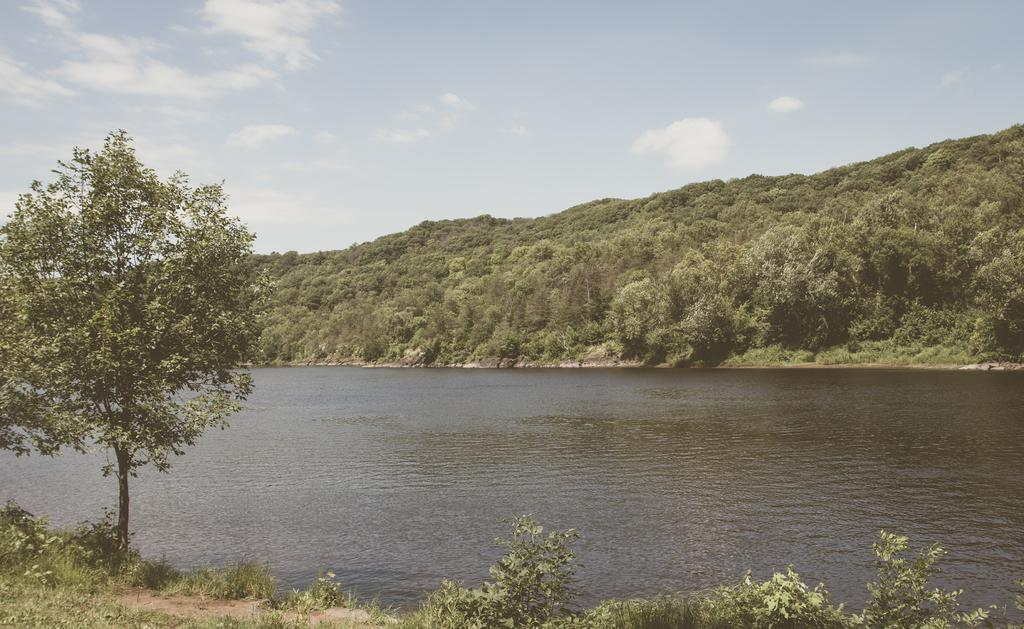What type of natural elements can be seen in the image? There are trees and hills in the image. What is located at the bottom of the image? There is water at the bottom of the image. What can be seen in the sky at the top of the image? There are clouds in the sky at the top of the image. What type of cracker is being used to paste the aunt's picture on the wall in the image? There is no cracker, paste, or picture of an aunt present in the image. 